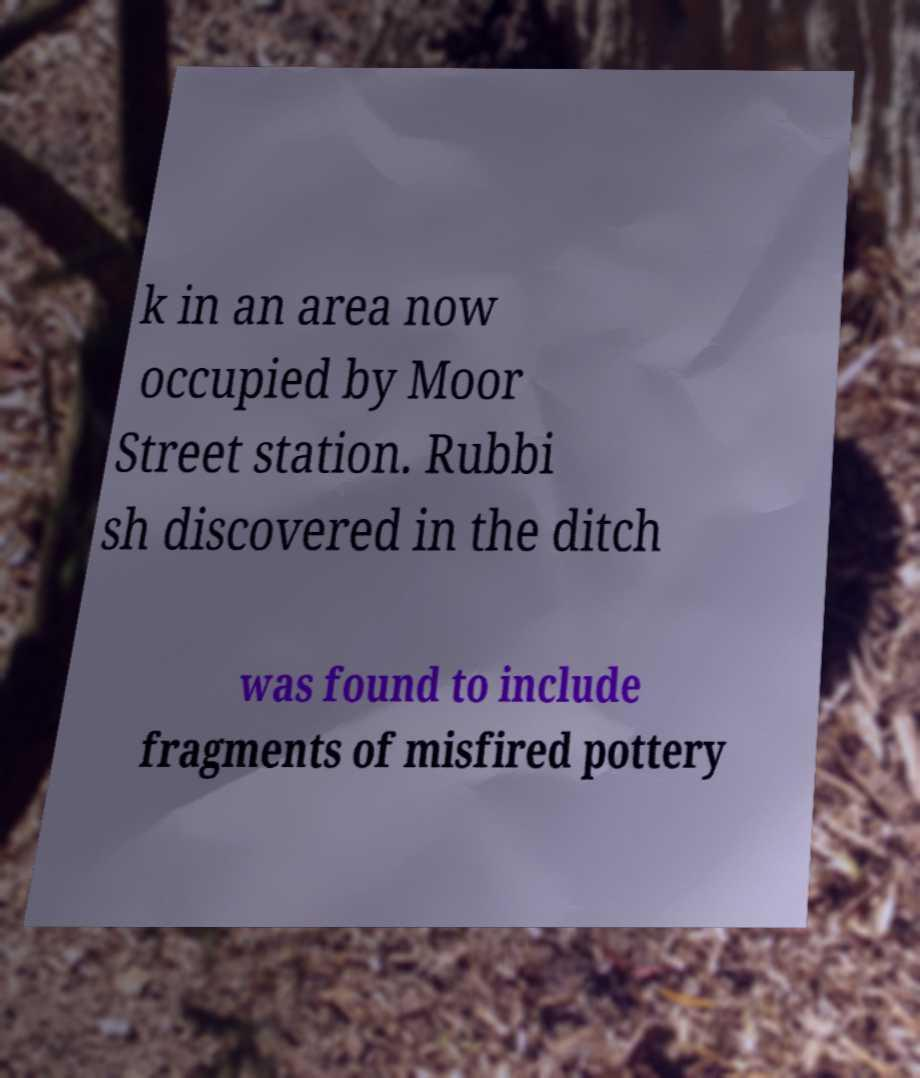For documentation purposes, I need the text within this image transcribed. Could you provide that? k in an area now occupied by Moor Street station. Rubbi sh discovered in the ditch was found to include fragments of misfired pottery 